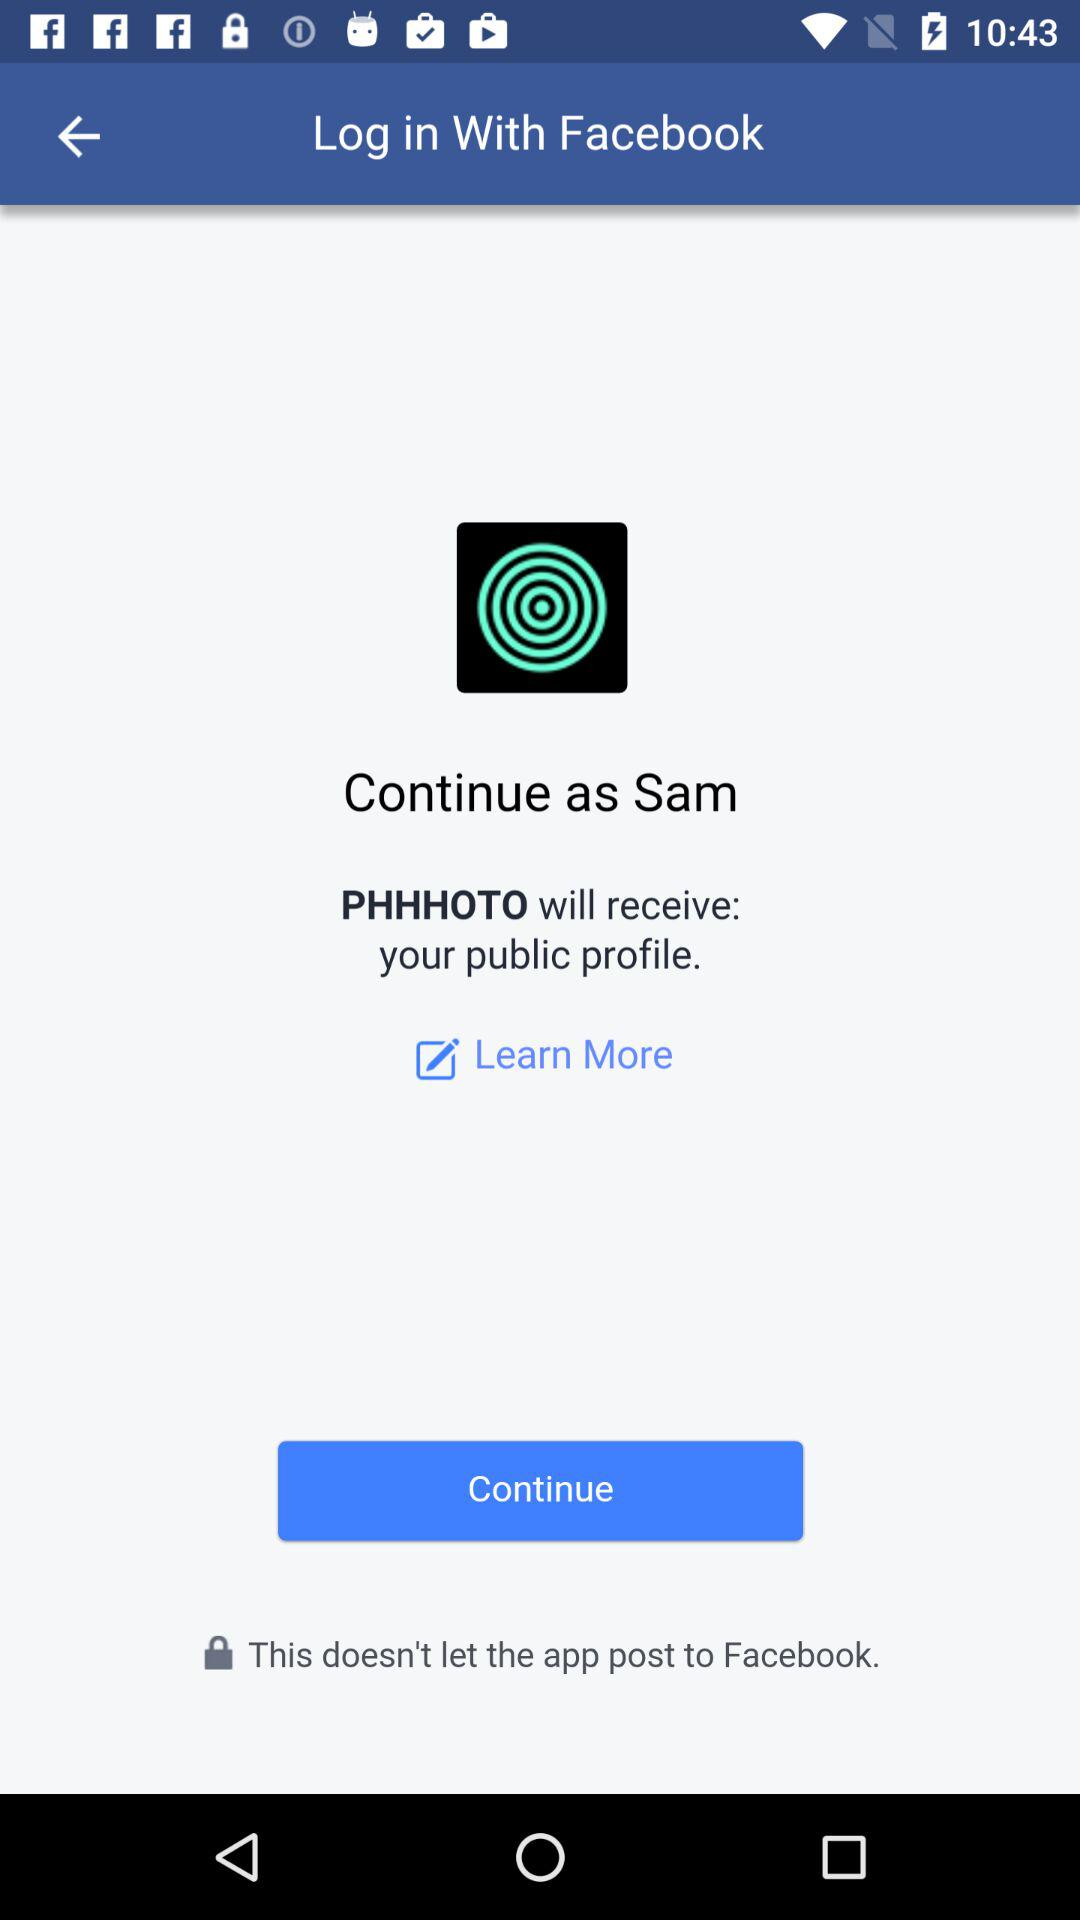What is the user name? The user name is "Sam". 